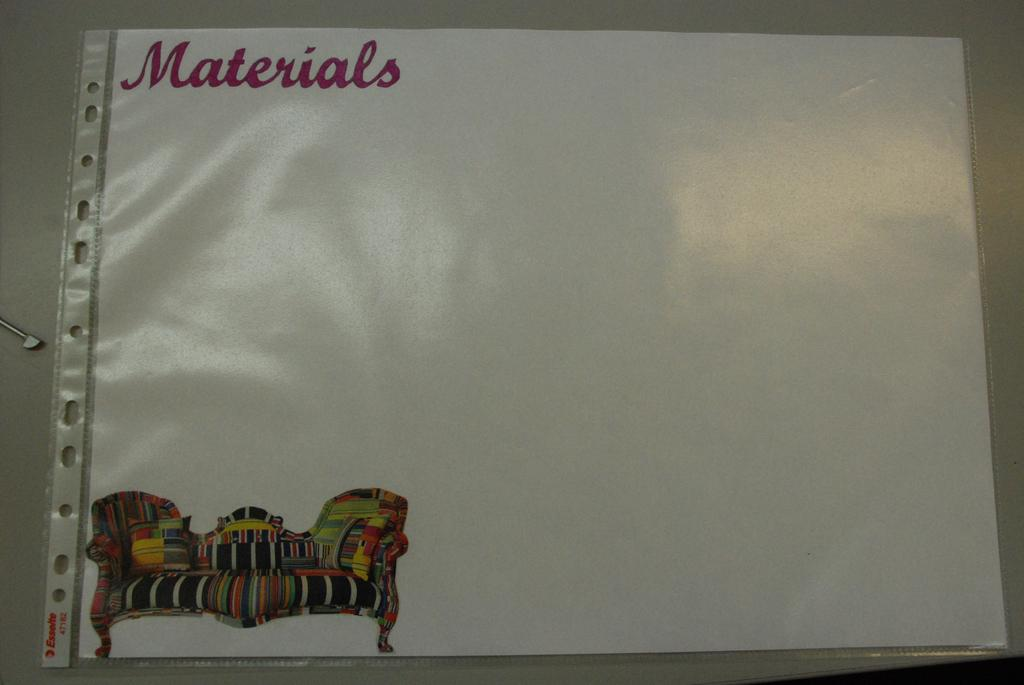<image>
Relay a brief, clear account of the picture shown. A laminated piece of paper with a picture of a sofa on it reads, "Materials". 